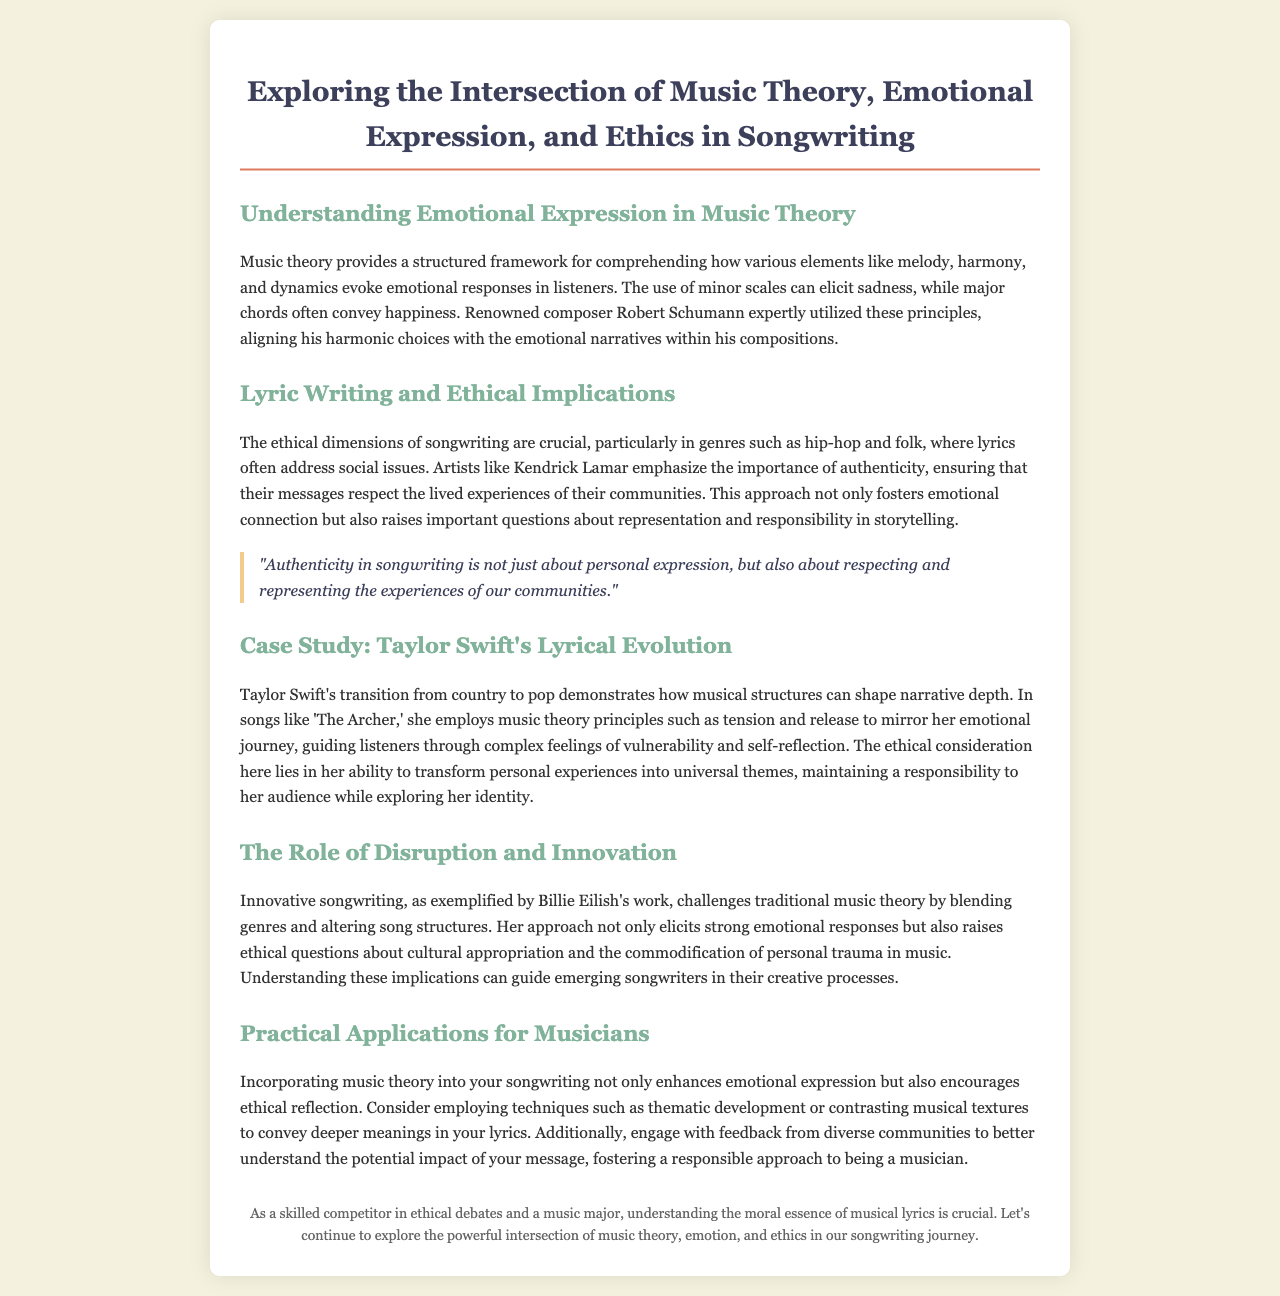What is the title of the document? The title is prominently displayed at the top of the document.
Answer: Exploring the Intersection of Music Theory, Emotional Expression, and Ethics in Songwriting Who is mentioned as utilizing music theory principles in their compositions? The document discusses composer Robert Schumann's use of music theory.
Answer: Robert Schumann Which artist emphasizes the importance of authenticity in songwriting? The document highlights Kendrick Lamar's focus on authenticity.
Answer: Kendrick Lamar What song by Taylor Swift is discussed in the case study? The case study references a specific song to illustrate her lyrical evolution.
Answer: The Archer What innovation does Billie Eilish bring to music theory? The text describes Billie Eilish's approach to music as blending genres and altering structures.
Answer: Blending genres What is a technique suggested to incorporate music theory in songwriting? The document gives specific techniques aimed at enhancing emotional expression in lyrics.
Answer: Thematic development What ethical consideration is related to Taylor Swift's songwriting? The text notes her responsibility to her audience while exploring personal themes.
Answer: Responsibility to her audience What type of songwriting does the document suggest can raise ethical questions? The document mentions innovative songwriting as a way to challenge traditional norms and raise issues.
Answer: Innovative songwriting What does the quote in the document discuss? The quote addresses the importance of respecting community experiences in songwriting.
Answer: Authenticity in songwriting 